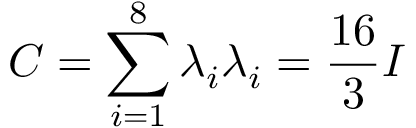Convert formula to latex. <formula><loc_0><loc_0><loc_500><loc_500>C = \sum _ { i = 1 } ^ { 8 } \lambda _ { i } \lambda _ { i } = { \frac { 1 6 } { 3 } } I</formula> 